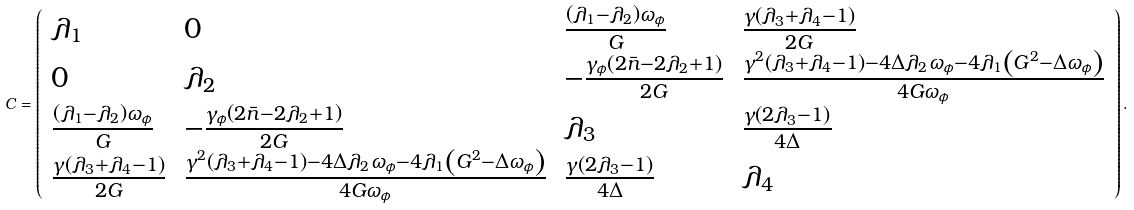Convert formula to latex. <formula><loc_0><loc_0><loc_500><loc_500>C = \left ( \begin{array} { l l l l } \lambda _ { 1 } & 0 & \frac { \left ( \lambda _ { 1 } - \lambda _ { 2 } \right ) \omega _ { \phi } } { G } & \frac { \gamma \left ( \lambda _ { 3 } + \lambda _ { 4 } - 1 \right ) } { 2 G } \\ 0 & \lambda _ { 2 } & - \frac { \gamma _ { \phi } \left ( 2 \bar { n } - 2 \lambda _ { 2 } + 1 \right ) } { 2 G } & \frac { \gamma ^ { 2 } ( \lambda _ { 3 } + \lambda _ { 4 } - 1 ) - 4 \Delta \lambda _ { 2 } \omega _ { \phi } - 4 \lambda _ { 1 } \left ( G ^ { 2 } - \Delta \omega _ { \phi } \right ) } { 4 G \omega _ { \phi } } \\ \frac { \left ( \lambda _ { 1 } - \lambda _ { 2 } \right ) \omega _ { \phi } } { G } & - \frac { \gamma _ { \phi } \left ( 2 \bar { n } - 2 \lambda _ { 2 } + 1 \right ) } { 2 G } & \lambda _ { 3 } & \frac { \gamma \left ( 2 \lambda _ { 3 } - 1 \right ) } { 4 \Delta } \\ \frac { \gamma \left ( \lambda _ { 3 } + \lambda _ { 4 } - 1 \right ) } { 2 G } & \frac { \gamma ^ { 2 } ( \lambda _ { 3 } + \lambda _ { 4 } - 1 ) - 4 \Delta \lambda _ { 2 } \omega _ { \phi } - 4 \lambda _ { 1 } \left ( G ^ { 2 } - \Delta \omega _ { \phi } \right ) } { 4 G \omega _ { \phi } } & \frac { \gamma \left ( 2 \lambda _ { 3 } - 1 \right ) } { 4 \Delta } & \lambda _ { 4 } \end{array} \right ) .</formula> 